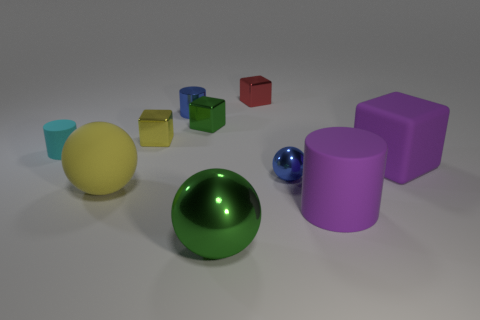Subtract 3 spheres. How many spheres are left? 0 Subtract all small cubes. How many cubes are left? 1 Subtract all yellow blocks. How many blue cylinders are left? 1 Subtract all blue cylinders. How many cylinders are left? 2 Subtract 0 gray cubes. How many objects are left? 10 Subtract all blocks. How many objects are left? 6 Subtract all gray cubes. Subtract all purple balls. How many cubes are left? 4 Subtract all purple matte objects. Subtract all large purple matte blocks. How many objects are left? 7 Add 3 shiny balls. How many shiny balls are left? 5 Add 8 cyan balls. How many cyan balls exist? 8 